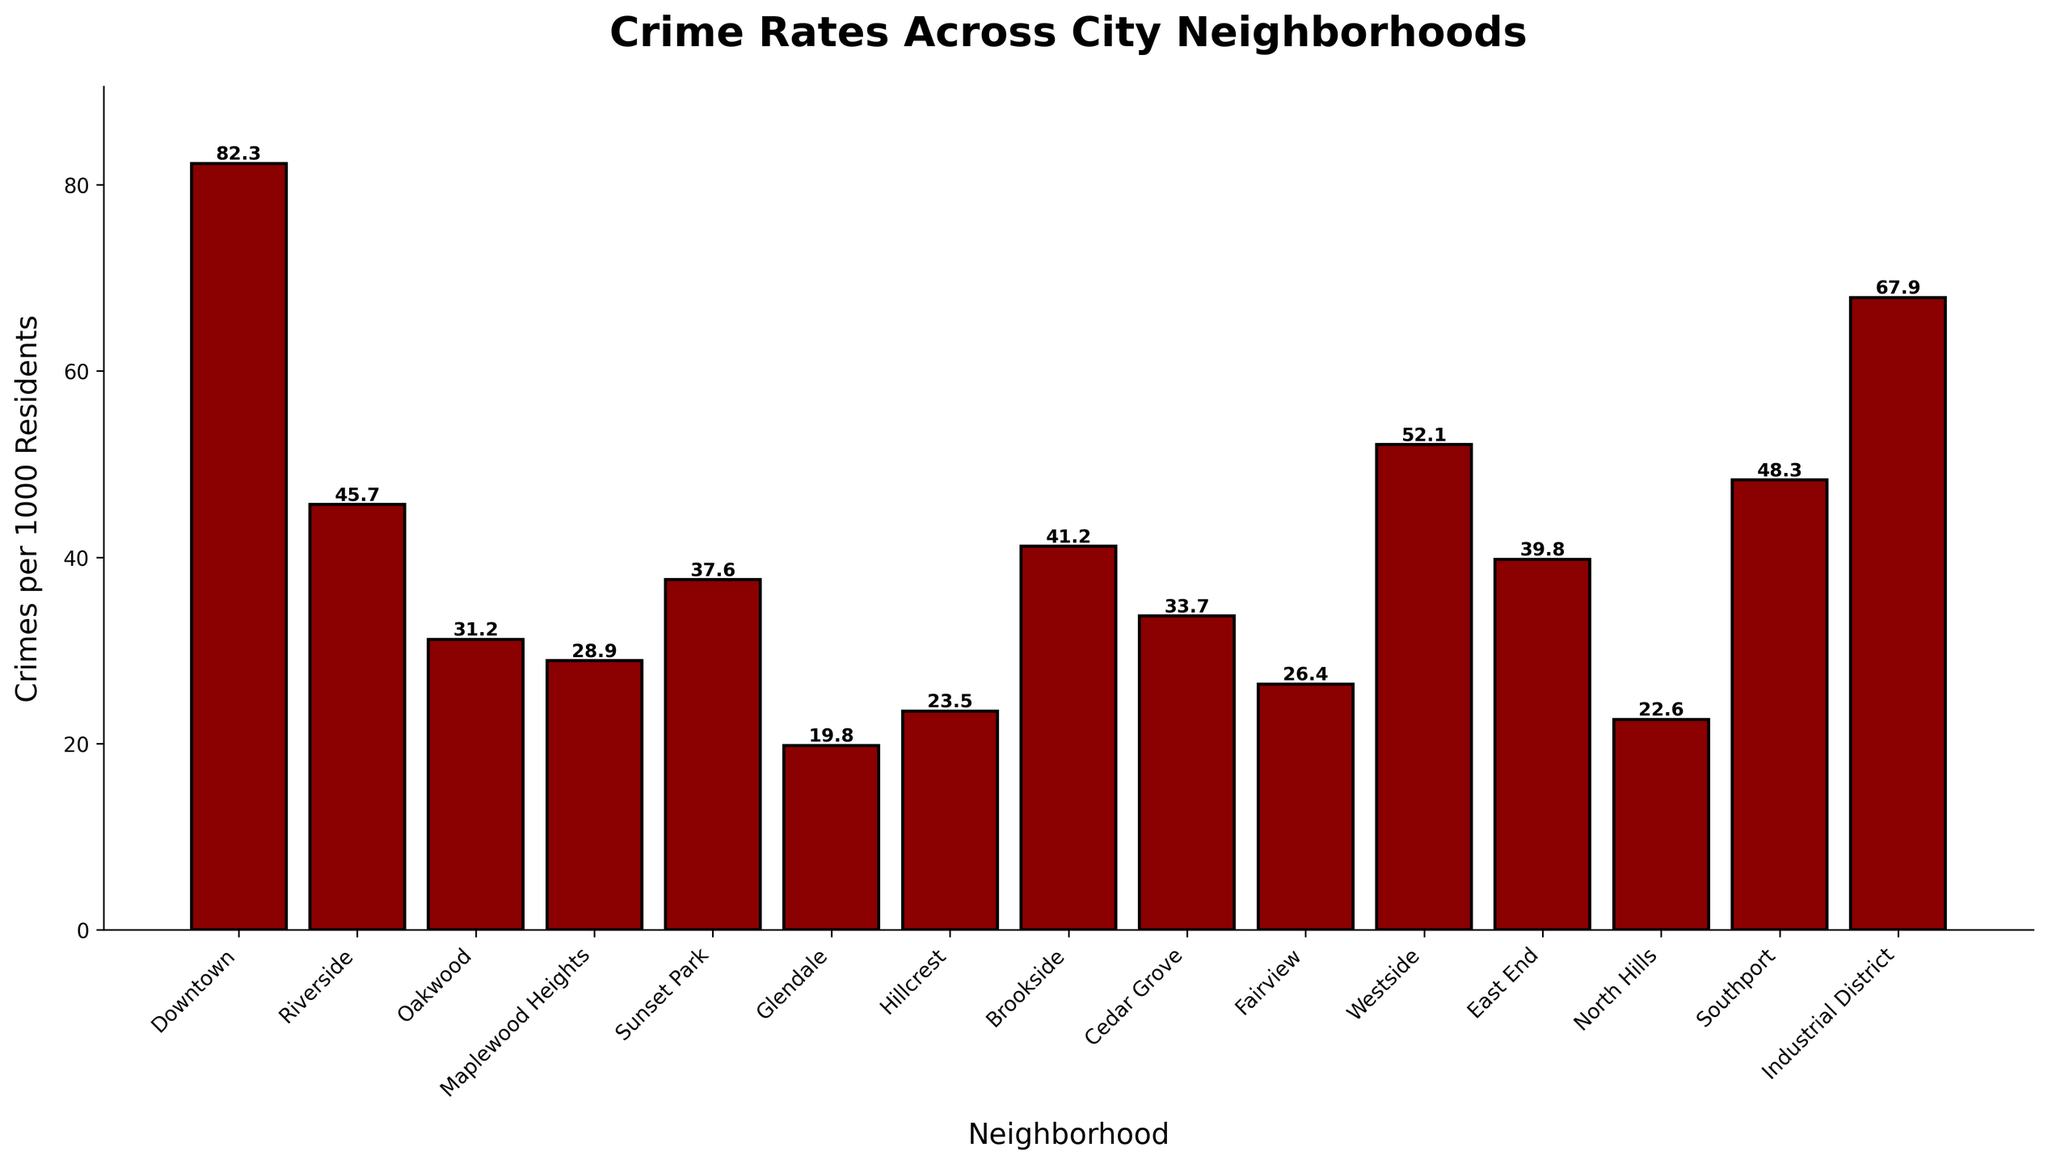Which neighborhood has the highest crime rate? Looking at the bar with the maximum height representing crimes per 1000 residents, Downtown appears to have the highest crime rate.
Answer: Downtown How many neighborhoods have a crime rate above 50 per 1000 residents? By identifying bars that exceed the 50 mark on the y-axis, we find that there are four neighborhoods: Downtown, Westside, Southport, and Industrial District.
Answer: 4 What is the difference in crime rates between Downtown and the neighborhood with the lowest crime rate? Downtown has 82.3 crimes per 1000 residents, and Glendale, with 19.8, has the lowest rate. The difference is calculated as 82.3 - 19.8.
Answer: 62.5 Which neighborhood has a higher crime rate, Riverside or Brookside? By comparing the heights of the bars for Riverside and Brookside, Riverside has a higher crime rate at 45.7 compared to Brookside's 41.2.
Answer: Riverside What is the average crime rate of the top 3 neighborhoods with the highest crime rates? The top 3 neighborhoods are Downtown (82.3), Industrial District (67.9), and Westside (52.1). Their average is calculated as (82.3 + 67.9 + 52.1) / 3 = 67.43.
Answer: 67.43 By how much does Southport's crime rate exceed Hillcrest's? Southport has a crime rate of 48.3, while Hillcrest has 23.5. The difference is 48.3 - 23.5.
Answer: 24.8 Which neighborhoods have crime rates between 20 and 40 per 1000 residents? By locating bars that fall within the 20-40 range on the y-axis, the neighborhoods are Oakwood (31.2), Maplewood Heights (28.9), Sunset Park (37.6), Cedar Grove (33.7), Fairview (26.4), and East End (39.8).
Answer: 6 What is the sum of crime rates for Cedar Grove and Fairview? Cedar Grove has 33.7 crimes per 1000 residents, and Fairview has 26.4. Their sum is 33.7 + 26.4.
Answer: 60.1 Which neighborhood has a lower crime rate, North Hills or Hillcrest? Comparing the bars for North Hills and Hillcrest, North Hills has a crime rate of 22.6, which is lower than Hillcrest's 23.5.
Answer: North Hills 